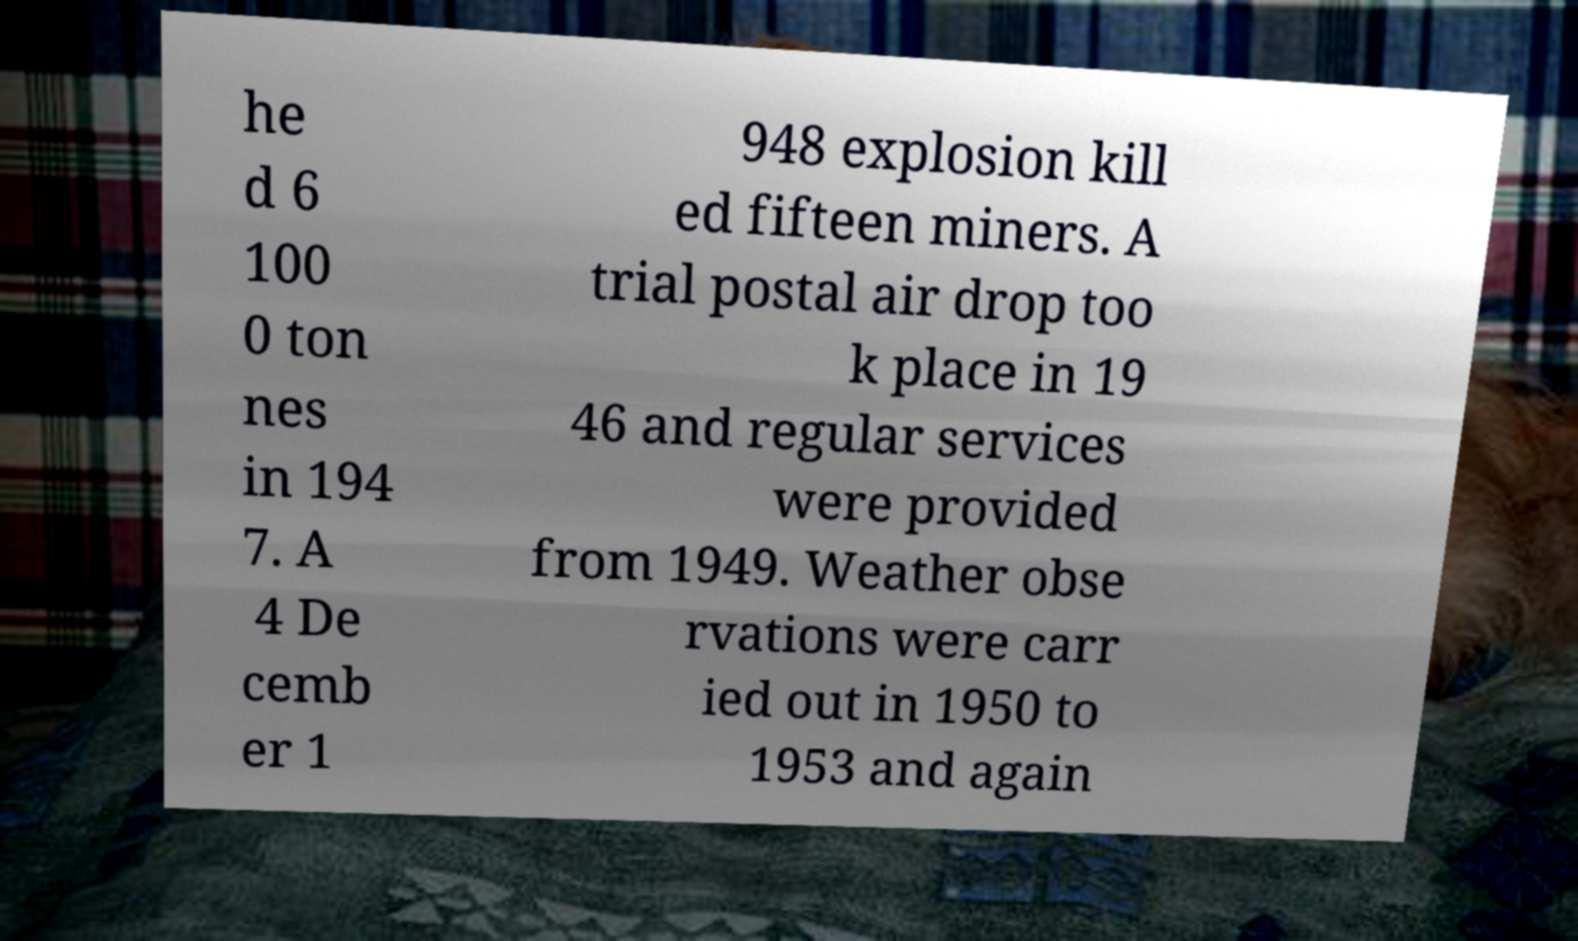Can you accurately transcribe the text from the provided image for me? he d 6 100 0 ton nes in 194 7. A 4 De cemb er 1 948 explosion kill ed fifteen miners. A trial postal air drop too k place in 19 46 and regular services were provided from 1949. Weather obse rvations were carr ied out in 1950 to 1953 and again 